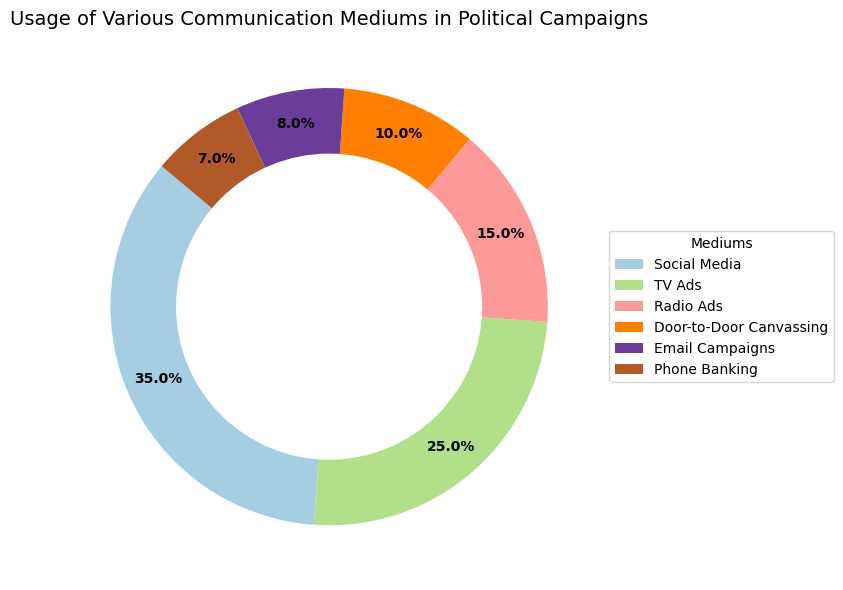Which communication medium is used the most? Observing the largest section of the pie chart, Social Media occupies the biggest portion.
Answer: Social Media Which communication medium has the smallest usage percentage? The smallest section of the pie chart belongs to Phone Banking at 7%.
Answer: Phone Banking How does the usage of TV Ads compare with Radio Ads? By comparing the sizes of the sections, TV Ads (25%) are larger than Radio Ads (15%).
Answer: TV Ads are greater than Radio Ads What is the combined usage percentage of Email Campaigns and Door-to-Door Canvassing? Email Campaigns are at 8% and Door-to-Door Canvassing is at 10%. Adding these gives 8% + 10% = 18%.
Answer: 18% What percentage of the total usage do Social Media and TV Ads account for? Adding the usage percentages of Social Media (35%) and TV Ads (25%) gives 35% + 25% = 60%.
Answer: 60% Is the usage of Radio Ads greater than half the usage of Social Media? Half the usage of Social Media is 35% / 2 = 17.5%. Radio Ads usage is 15%, which is less than 17.5%.
Answer: No Which two communication mediums have a combined usage greater than 50%? Social Media (35%) and TV Ads (25%) combined make up 35% + 25% = 60%, which is greater than 50%.
Answer: Social Media and TV Ads What is the difference in usage between Door-to-Door Canvassing and Phone Banking? Door-to-Door Canvassing has a usage of 10%, while Phone Banking has a usage of 7%. The difference is 10% - 7% = 3%.
Answer: 3% Which communication medium(s) use closest to one-quarter of the total usage? TV Ads have a usage of 25%, which is exactly one-quarter of 100%.
Answer: TV Ads What is the total usage percentage of all mediums? Summing the percentages of all mediums: 35% + 25% + 15% + 10% + 8% + 7% = 100%.
Answer: 100% 